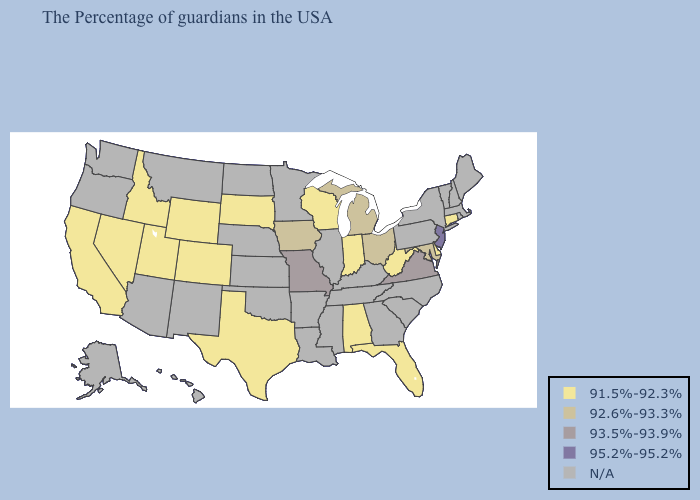What is the value of Minnesota?
Write a very short answer. N/A. What is the highest value in the USA?
Short answer required. 95.2%-95.2%. Does the map have missing data?
Concise answer only. Yes. Does the map have missing data?
Concise answer only. Yes. Does West Virginia have the lowest value in the South?
Give a very brief answer. Yes. Which states have the lowest value in the USA?
Write a very short answer. Connecticut, Delaware, West Virginia, Florida, Indiana, Alabama, Wisconsin, Texas, South Dakota, Wyoming, Colorado, Utah, Idaho, Nevada, California. What is the value of New York?
Give a very brief answer. N/A. Name the states that have a value in the range 95.2%-95.2%?
Concise answer only. New Jersey. Name the states that have a value in the range N/A?
Concise answer only. Maine, Massachusetts, Rhode Island, New Hampshire, Vermont, New York, Pennsylvania, North Carolina, South Carolina, Georgia, Kentucky, Tennessee, Illinois, Mississippi, Louisiana, Arkansas, Minnesota, Kansas, Nebraska, Oklahoma, North Dakota, New Mexico, Montana, Arizona, Washington, Oregon, Alaska, Hawaii. Does California have the lowest value in the USA?
Give a very brief answer. Yes. Name the states that have a value in the range N/A?
Quick response, please. Maine, Massachusetts, Rhode Island, New Hampshire, Vermont, New York, Pennsylvania, North Carolina, South Carolina, Georgia, Kentucky, Tennessee, Illinois, Mississippi, Louisiana, Arkansas, Minnesota, Kansas, Nebraska, Oklahoma, North Dakota, New Mexico, Montana, Arizona, Washington, Oregon, Alaska, Hawaii. Name the states that have a value in the range 92.6%-93.3%?
Keep it brief. Maryland, Ohio, Michigan, Iowa. Name the states that have a value in the range N/A?
Quick response, please. Maine, Massachusetts, Rhode Island, New Hampshire, Vermont, New York, Pennsylvania, North Carolina, South Carolina, Georgia, Kentucky, Tennessee, Illinois, Mississippi, Louisiana, Arkansas, Minnesota, Kansas, Nebraska, Oklahoma, North Dakota, New Mexico, Montana, Arizona, Washington, Oregon, Alaska, Hawaii. Name the states that have a value in the range N/A?
Short answer required. Maine, Massachusetts, Rhode Island, New Hampshire, Vermont, New York, Pennsylvania, North Carolina, South Carolina, Georgia, Kentucky, Tennessee, Illinois, Mississippi, Louisiana, Arkansas, Minnesota, Kansas, Nebraska, Oklahoma, North Dakota, New Mexico, Montana, Arizona, Washington, Oregon, Alaska, Hawaii. 